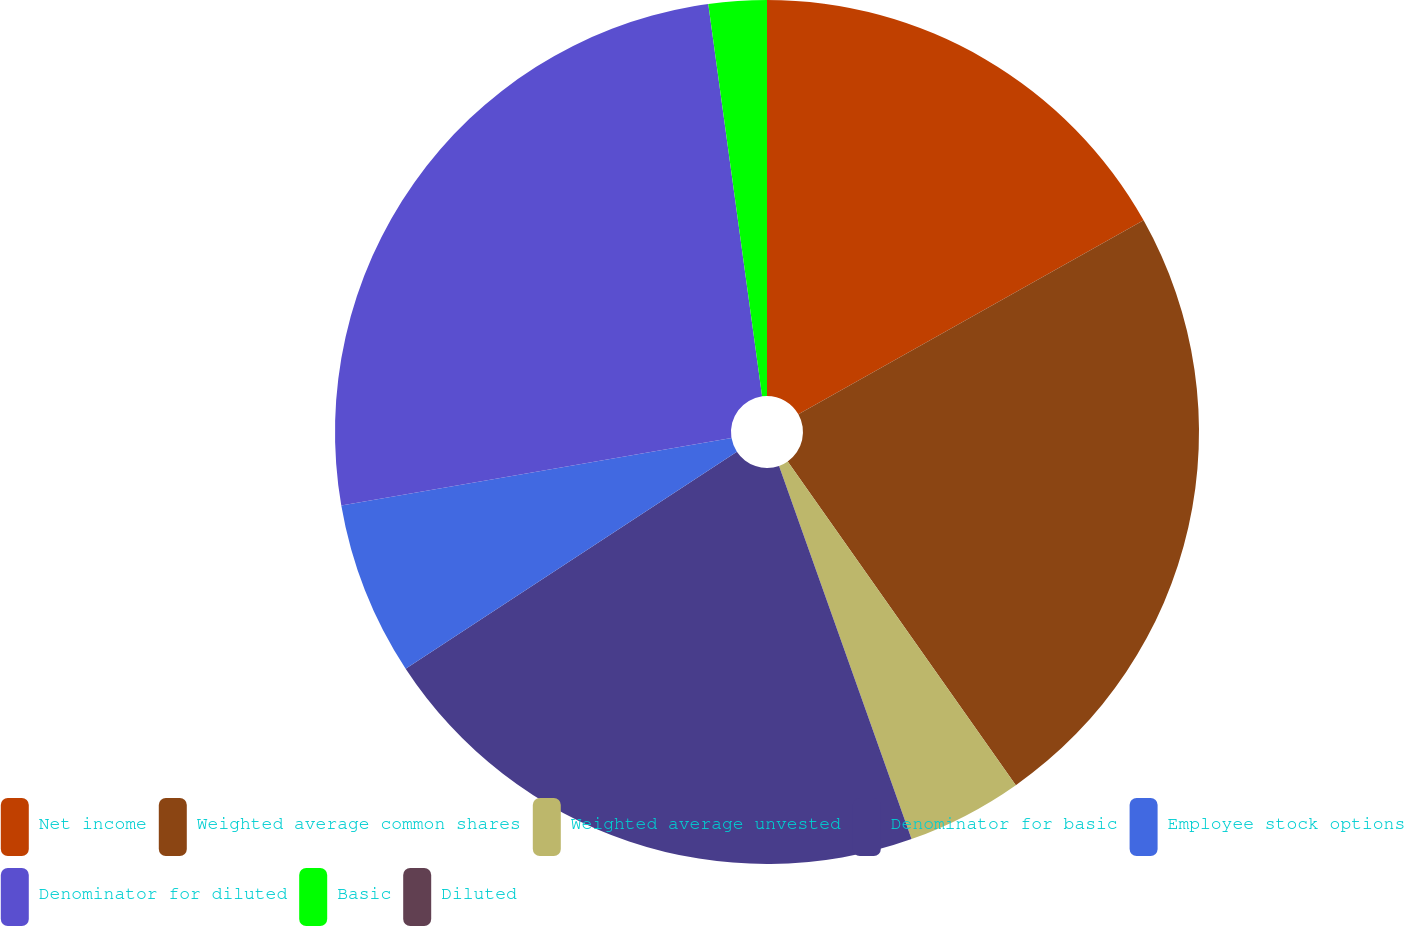Convert chart to OTSL. <chart><loc_0><loc_0><loc_500><loc_500><pie_chart><fcel>Net income<fcel>Weighted average common shares<fcel>Weighted average unvested<fcel>Denominator for basic<fcel>Employee stock options<fcel>Denominator for diluted<fcel>Basic<fcel>Diluted<nl><fcel>16.85%<fcel>23.38%<fcel>4.34%<fcel>21.2%<fcel>6.51%<fcel>25.55%<fcel>2.17%<fcel>0.0%<nl></chart> 